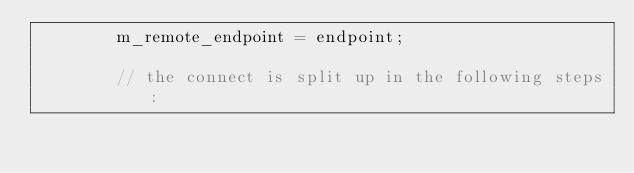<code> <loc_0><loc_0><loc_500><loc_500><_C++_>		m_remote_endpoint = endpoint;

		// the connect is split up in the following steps:</code> 